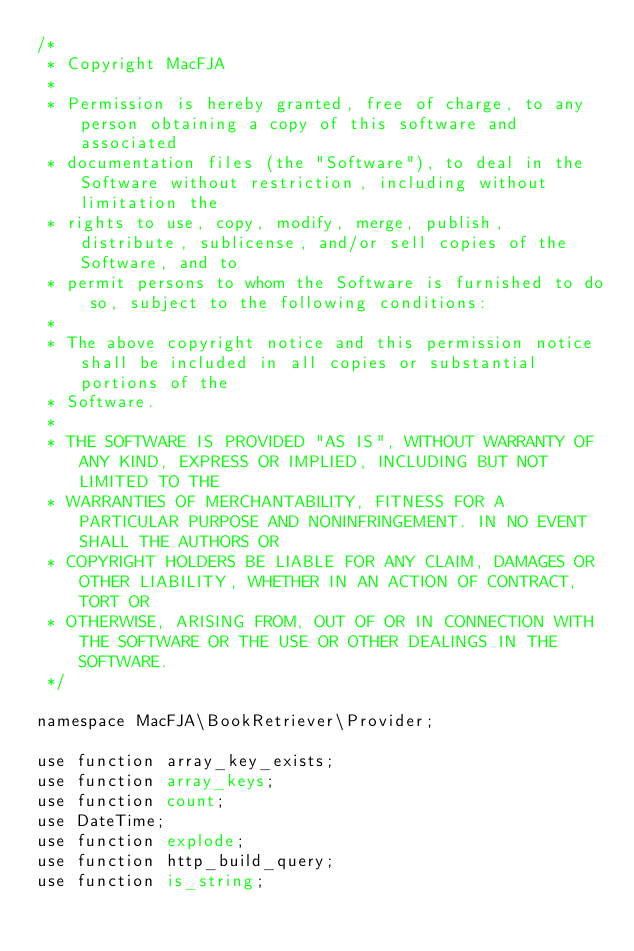Convert code to text. <code><loc_0><loc_0><loc_500><loc_500><_PHP_>/*
 * Copyright MacFJA
 *
 * Permission is hereby granted, free of charge, to any person obtaining a copy of this software and associated
 * documentation files (the "Software"), to deal in the Software without restriction, including without limitation the
 * rights to use, copy, modify, merge, publish, distribute, sublicense, and/or sell copies of the Software, and to
 * permit persons to whom the Software is furnished to do so, subject to the following conditions:
 *
 * The above copyright notice and this permission notice shall be included in all copies or substantial portions of the
 * Software.
 *
 * THE SOFTWARE IS PROVIDED "AS IS", WITHOUT WARRANTY OF ANY KIND, EXPRESS OR IMPLIED, INCLUDING BUT NOT LIMITED TO THE
 * WARRANTIES OF MERCHANTABILITY, FITNESS FOR A PARTICULAR PURPOSE AND NONINFRINGEMENT. IN NO EVENT SHALL THE AUTHORS OR
 * COPYRIGHT HOLDERS BE LIABLE FOR ANY CLAIM, DAMAGES OR OTHER LIABILITY, WHETHER IN AN ACTION OF CONTRACT, TORT OR
 * OTHERWISE, ARISING FROM, OUT OF OR IN CONNECTION WITH THE SOFTWARE OR THE USE OR OTHER DEALINGS IN THE SOFTWARE.
 */

namespace MacFJA\BookRetriever\Provider;

use function array_key_exists;
use function array_keys;
use function count;
use DateTime;
use function explode;
use function http_build_query;
use function is_string;</code> 